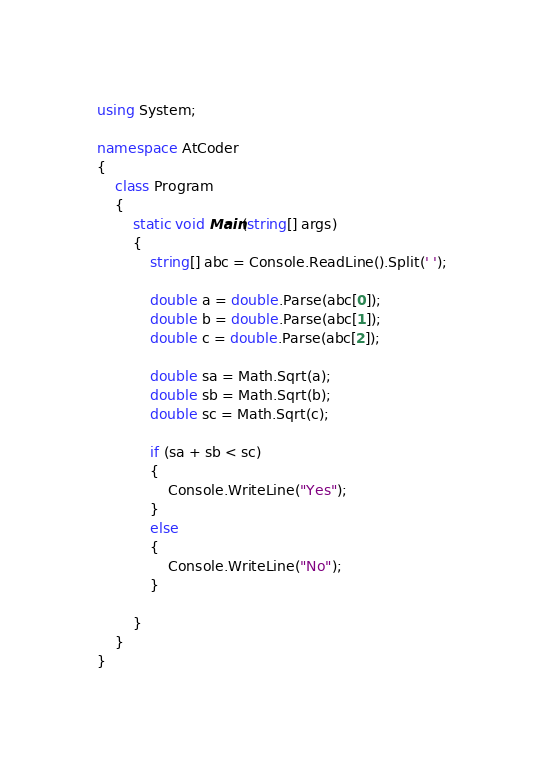Convert code to text. <code><loc_0><loc_0><loc_500><loc_500><_C#_>using System;

namespace AtCoder
{
    class Program
    {
        static void Main(string[] args)
        {
            string[] abc = Console.ReadLine().Split(' ');

            double a = double.Parse(abc[0]);
            double b = double.Parse(abc[1]);
            double c = double.Parse(abc[2]);

            double sa = Math.Sqrt(a);
            double sb = Math.Sqrt(b);
            double sc = Math.Sqrt(c);

            if (sa + sb < sc)
            {
                Console.WriteLine("Yes");
            }
            else
            {
                Console.WriteLine("No");
            }

        }
    }
}
</code> 